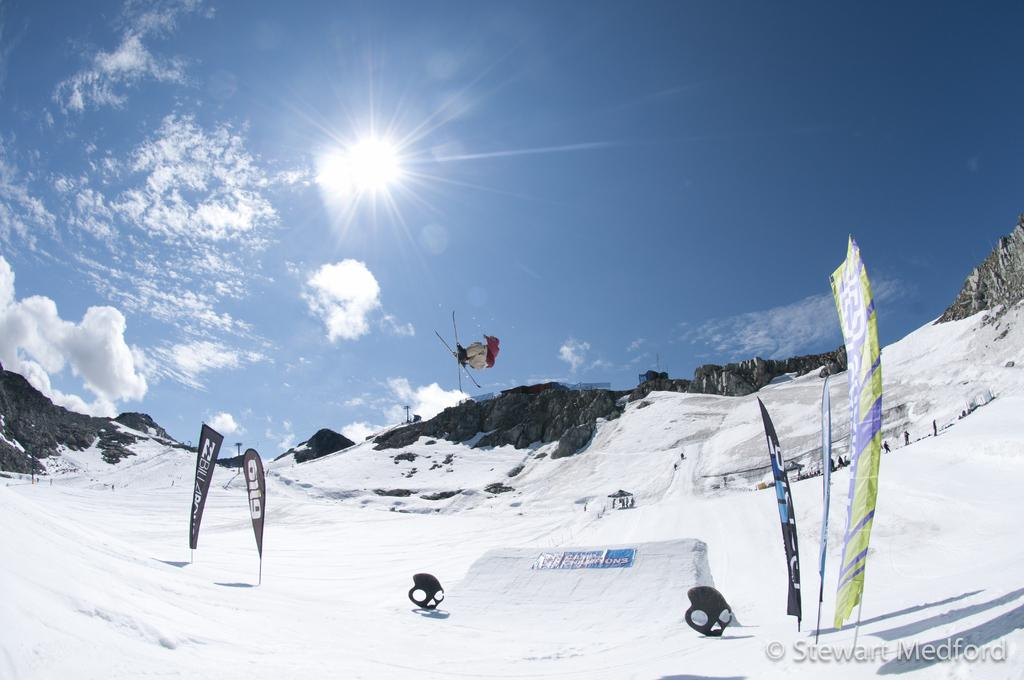What is the primary feature of the landscape in the image? There is snow in the image. What is the person in the image doing? The person is wearing skis and is in the air. What can be seen in the distance in the image? There are mountains in the background of the image. What type of doll can be seen floating on the ocean in the image? There is no ocean or doll present in the image; it features snow, a person skiing, and mountains in the background. 